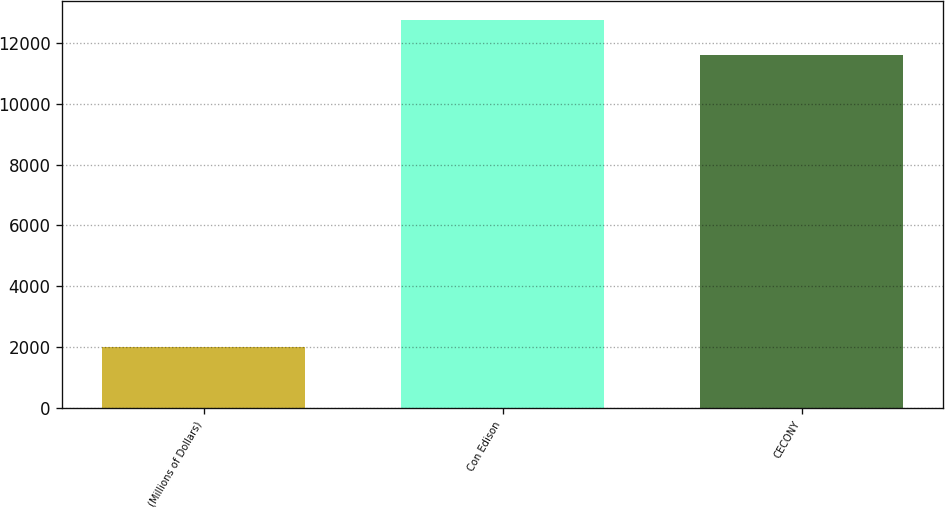<chart> <loc_0><loc_0><loc_500><loc_500><bar_chart><fcel>(Millions of Dollars)<fcel>Con Edison<fcel>CECONY<nl><fcel>2011<fcel>12744<fcel>11593<nl></chart> 